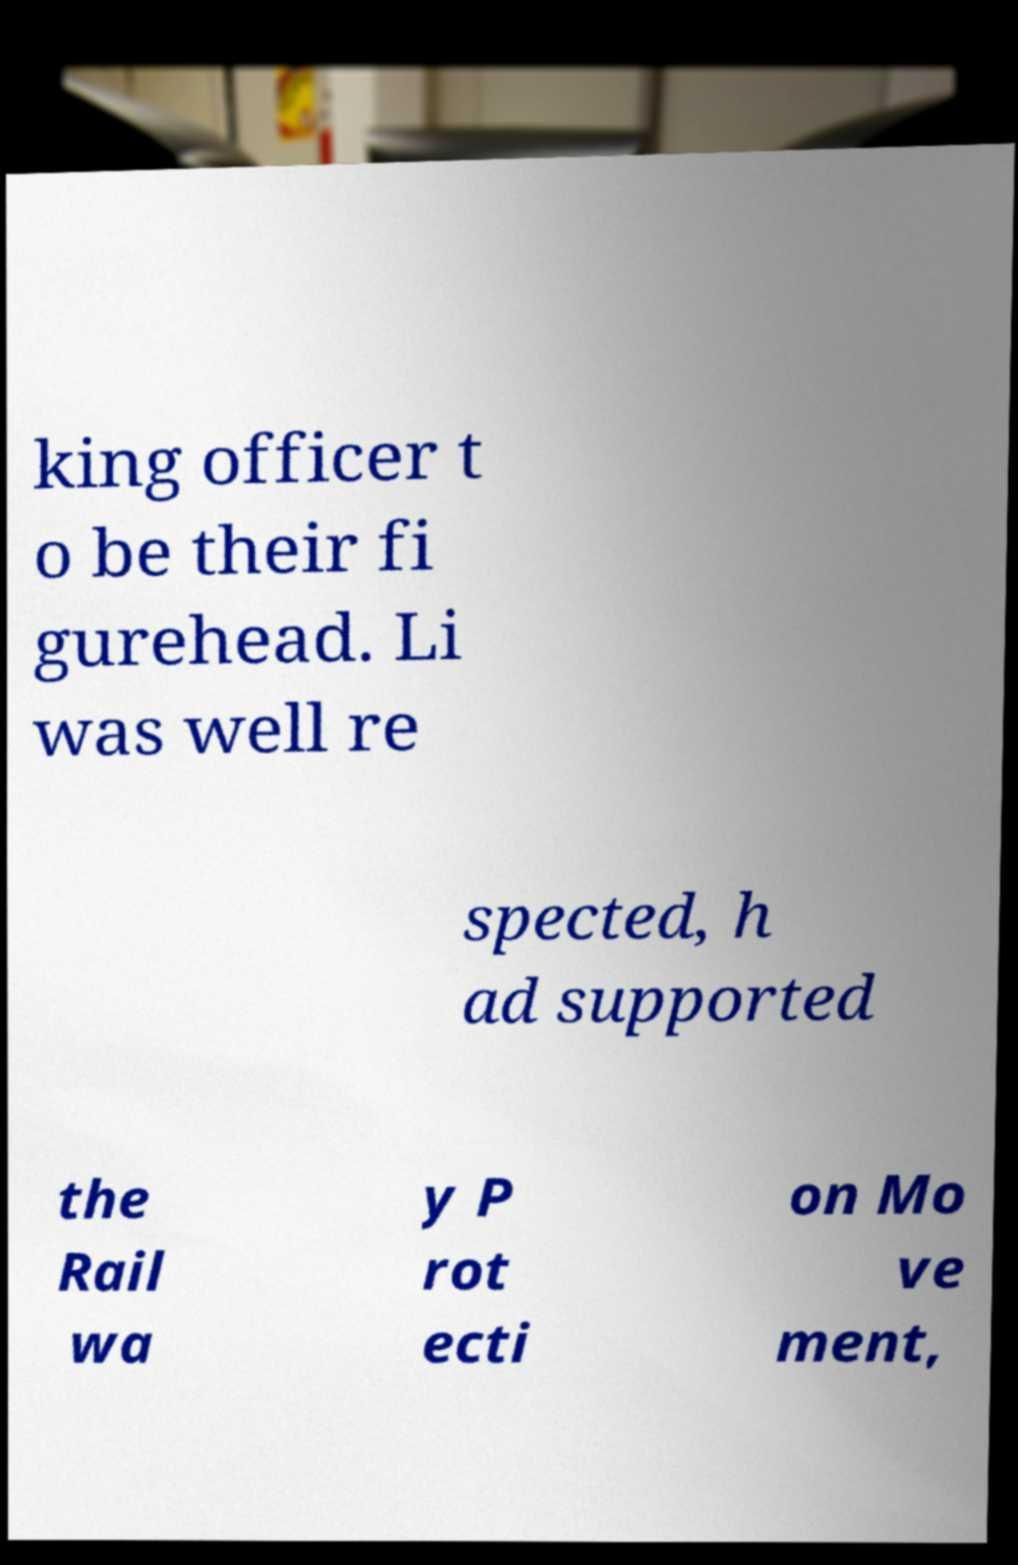Please read and relay the text visible in this image. What does it say? king officer t o be their fi gurehead. Li was well re spected, h ad supported the Rail wa y P rot ecti on Mo ve ment, 